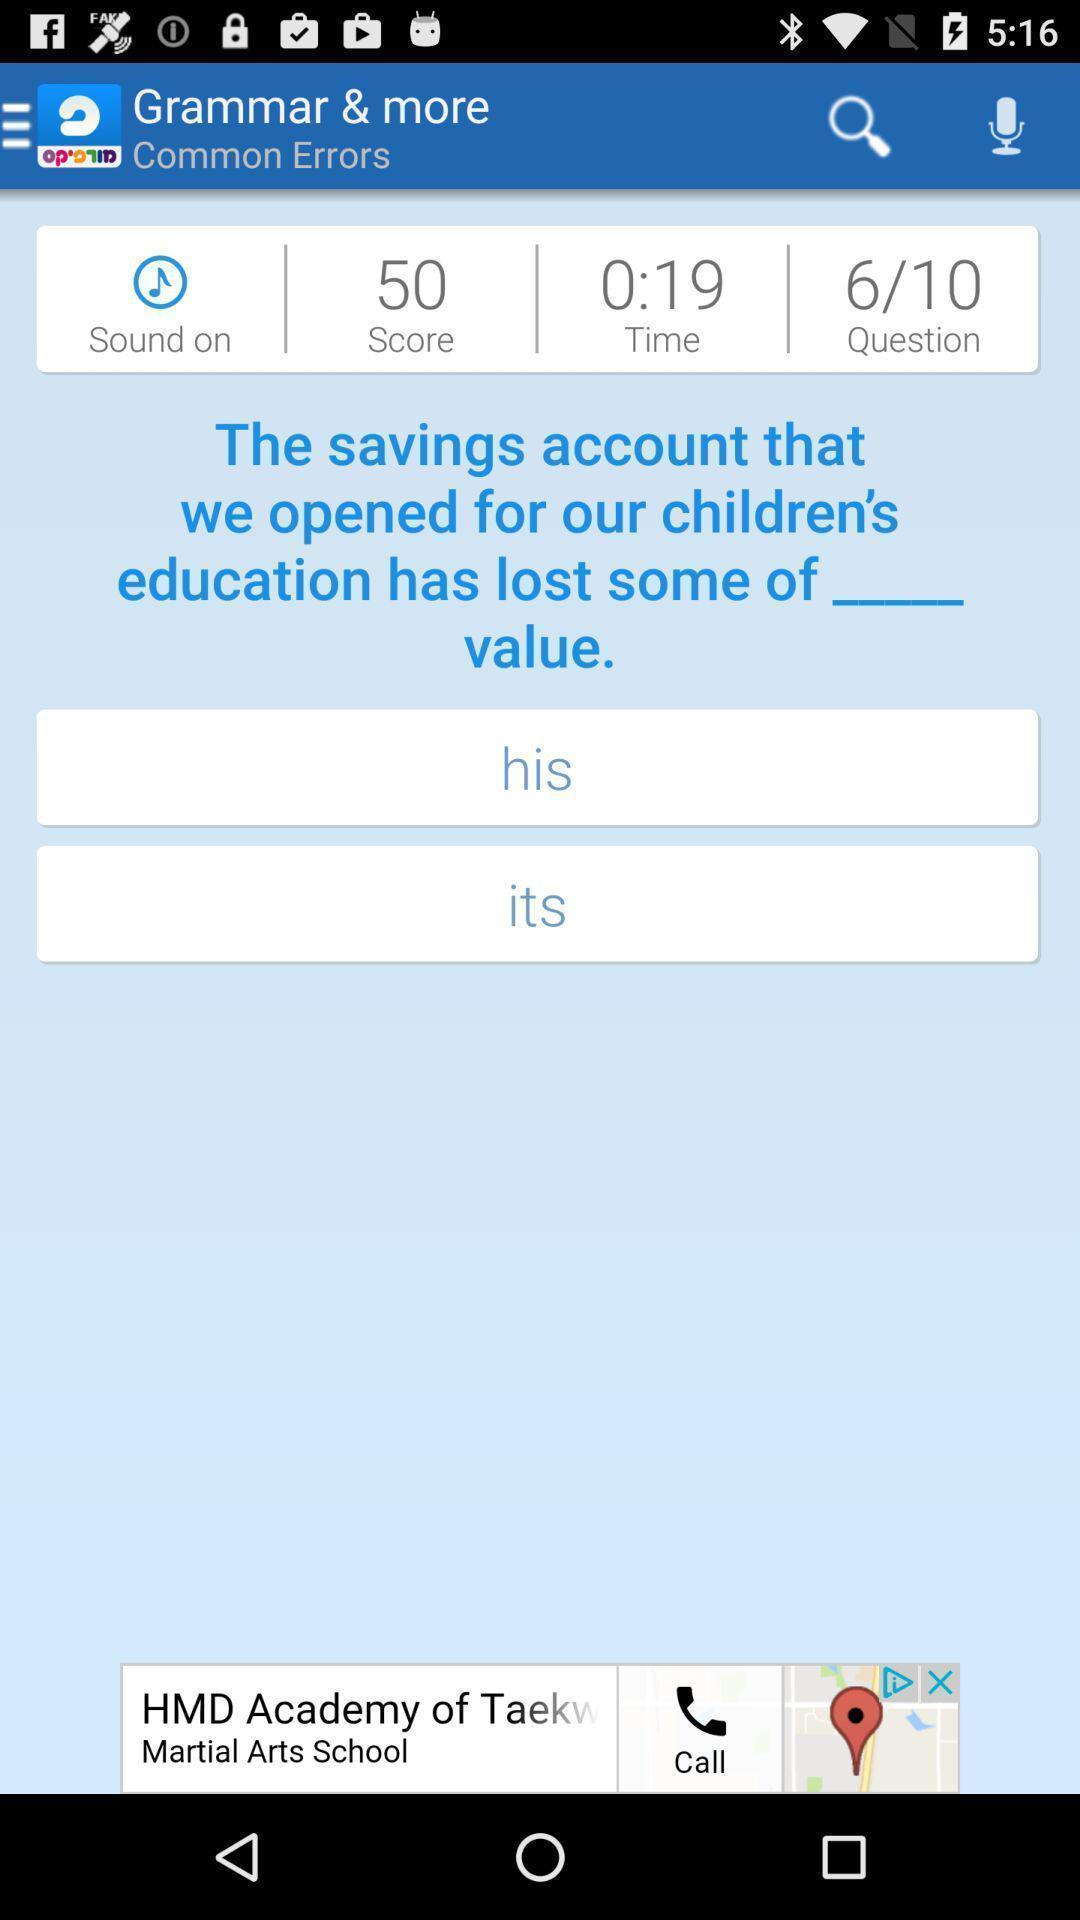Give me a narrative description of this picture. Page for learning grammar with a question and options. 